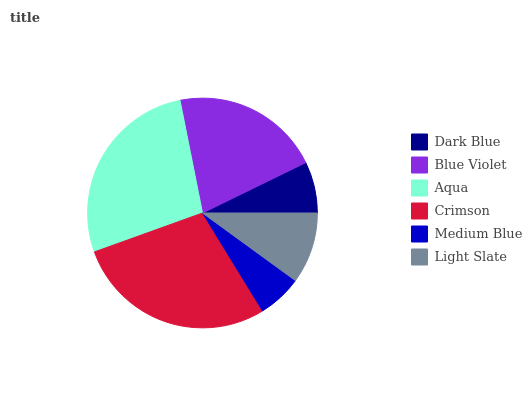Is Medium Blue the minimum?
Answer yes or no. Yes. Is Crimson the maximum?
Answer yes or no. Yes. Is Blue Violet the minimum?
Answer yes or no. No. Is Blue Violet the maximum?
Answer yes or no. No. Is Blue Violet greater than Dark Blue?
Answer yes or no. Yes. Is Dark Blue less than Blue Violet?
Answer yes or no. Yes. Is Dark Blue greater than Blue Violet?
Answer yes or no. No. Is Blue Violet less than Dark Blue?
Answer yes or no. No. Is Blue Violet the high median?
Answer yes or no. Yes. Is Light Slate the low median?
Answer yes or no. Yes. Is Crimson the high median?
Answer yes or no. No. Is Medium Blue the low median?
Answer yes or no. No. 